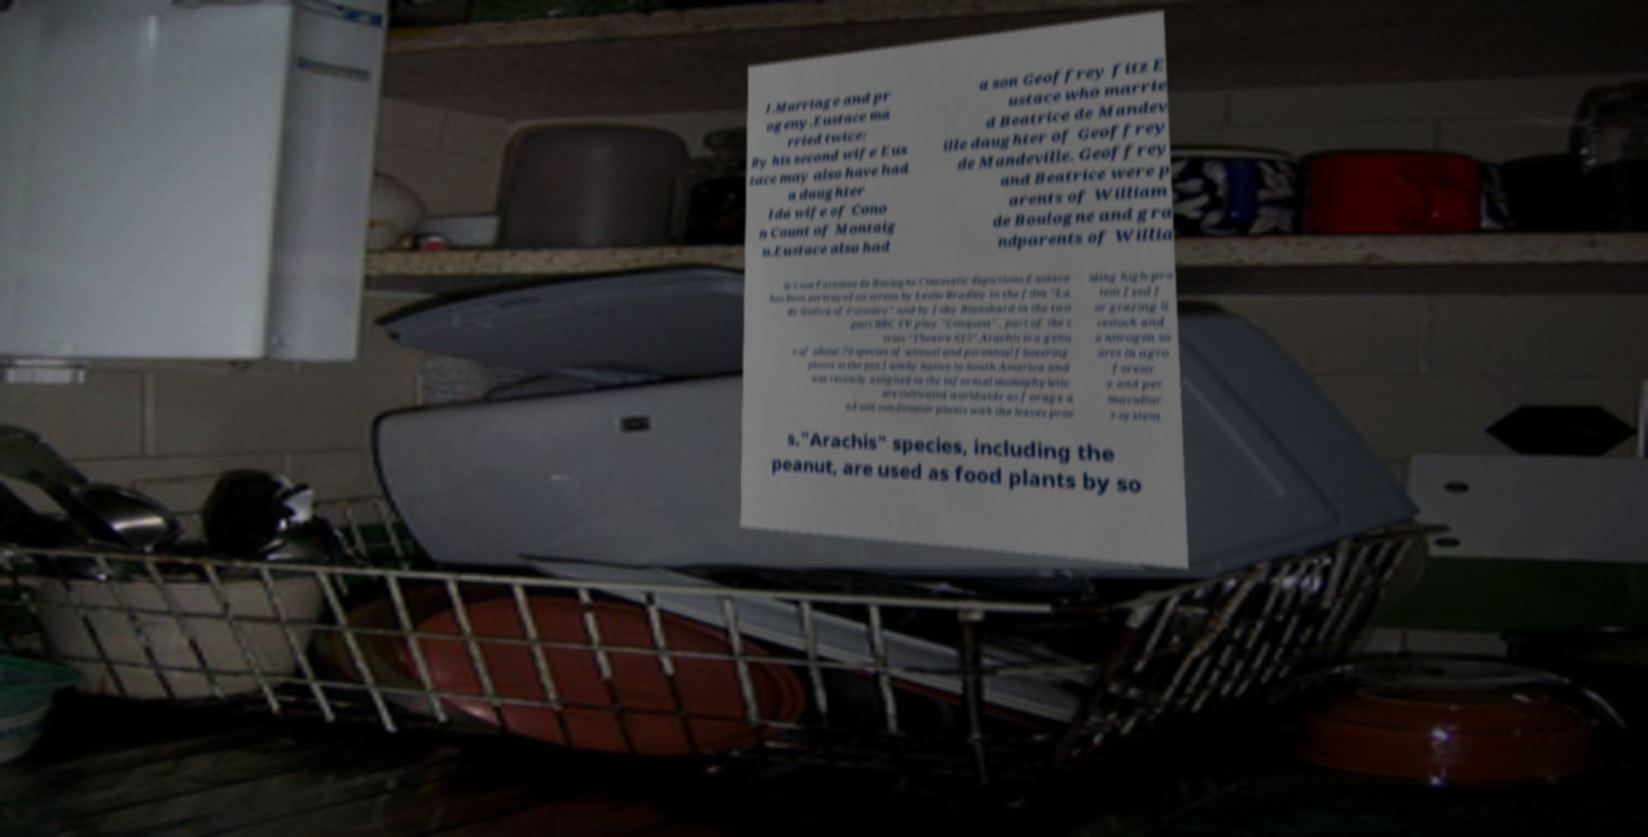What messages or text are displayed in this image? I need them in a readable, typed format. I.Marriage and pr ogeny.Eustace ma rried twice: By his second wife Eus tace may also have had a daughter Ida wife of Cono n Count of Montaig u.Eustace also had a son Geoffrey fitz E ustace who marrie d Beatrice de Mandev ille daughter of Geoffrey de Mandeville. Geoffrey and Beatrice were p arents of William de Boulogne and gra ndparents of Willia m's son Faramus de Boulogne.Cinematic depictions.Eustace has been portrayed on screen by Leslie Bradley in the film "La dy Godiva of Coventry" and by Joby Blanshard in the two -part BBC TV play "Conquest" , part of the s eries "Theatre 625".Arachis is a genu s of about 70 species of annual and perennial flowering plants in the pea family native to South America and was recently assigned to the informal monophyletic are cultivated worldwide as forage a nd soil conditioner plants with the leaves prov iding high-pro tein feed f or grazing li vestock and a nitrogen so urce in agro forestr y and per macultur e system s."Arachis" species, including the peanut, are used as food plants by so 